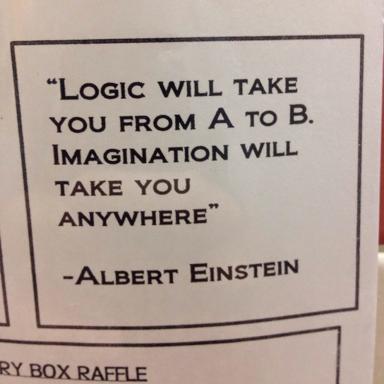What does the quote imply about the power of imagination compared to logic? The quote draws a significant contrast between logic and imagination. It suggests that while logic is crucial for navigating known paths from point A to B, imagination breaks boundaries, propelling us into a world of infinite possibilities and inspiring innovations that defy conventional logic. 